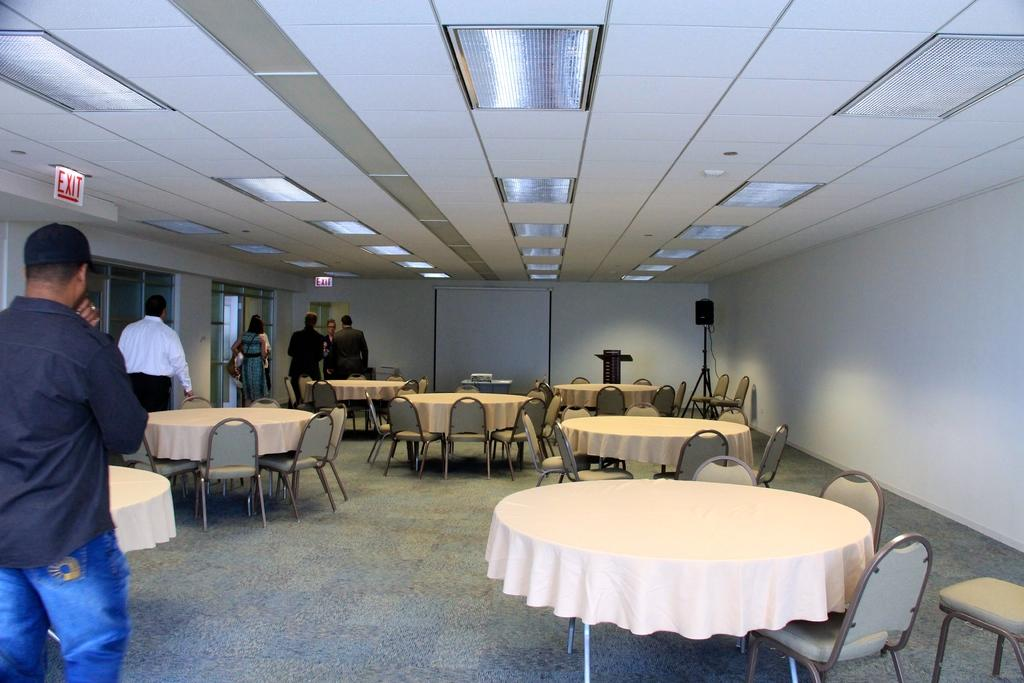What can be seen in the image? There are people standing in the image. What furniture is present in the image? There are chairs and tables in the image. How many people are visible in the image? The number of people cannot be determined from the provided facts. How many ladybugs are crawling on the chairs in the image? There is no mention of ladybugs in the provided facts, so we cannot determine their presence or quantity in the image. 